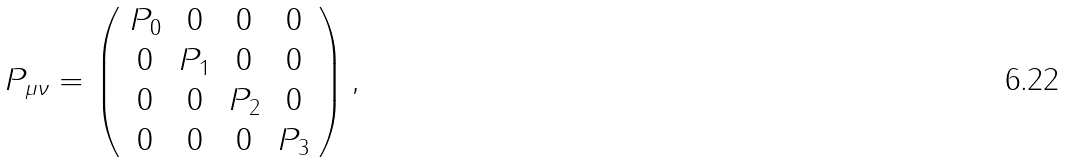<formula> <loc_0><loc_0><loc_500><loc_500>P _ { \mu \nu } = \left ( \begin{array} { c c c c } P _ { 0 } & 0 & 0 & 0 \\ 0 & P _ { 1 } & 0 & 0 \\ 0 & 0 & P _ { 2 } & 0 \\ 0 & 0 & 0 & P _ { 3 } \end{array} \right ) ,</formula> 